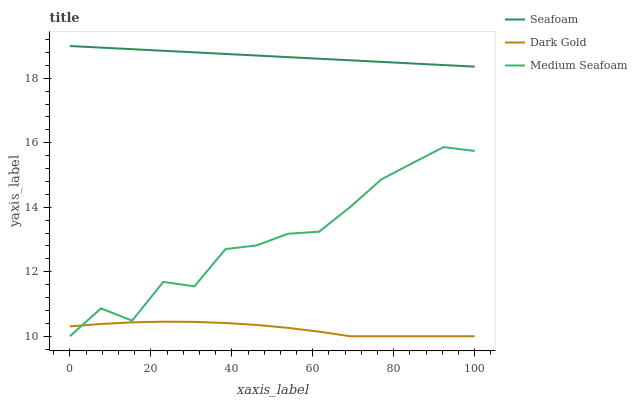Does Dark Gold have the minimum area under the curve?
Answer yes or no. Yes. Does Seafoam have the maximum area under the curve?
Answer yes or no. Yes. Does Seafoam have the minimum area under the curve?
Answer yes or no. No. Does Dark Gold have the maximum area under the curve?
Answer yes or no. No. Is Seafoam the smoothest?
Answer yes or no. Yes. Is Medium Seafoam the roughest?
Answer yes or no. Yes. Is Dark Gold the smoothest?
Answer yes or no. No. Is Dark Gold the roughest?
Answer yes or no. No. Does Seafoam have the lowest value?
Answer yes or no. No. Does Dark Gold have the highest value?
Answer yes or no. No. Is Dark Gold less than Seafoam?
Answer yes or no. Yes. Is Seafoam greater than Medium Seafoam?
Answer yes or no. Yes. Does Dark Gold intersect Seafoam?
Answer yes or no. No. 